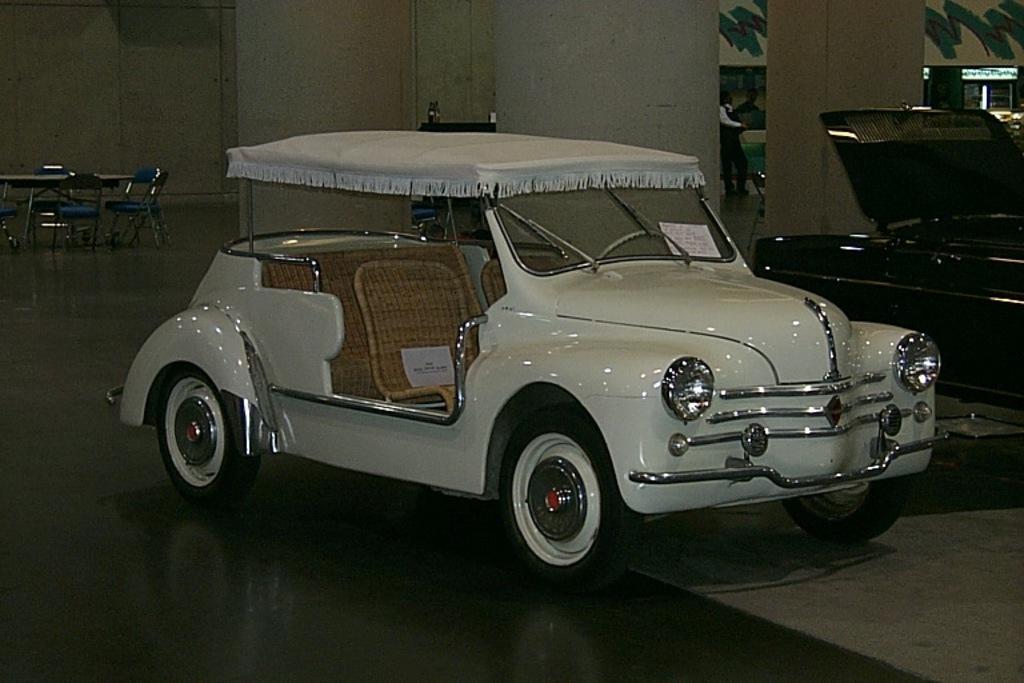In one or two sentences, can you explain what this image depicts? This image consists of cars and there are tables and chairs on the left side. There is a person standing in the middle. In the middle there is a car which is in white color. 